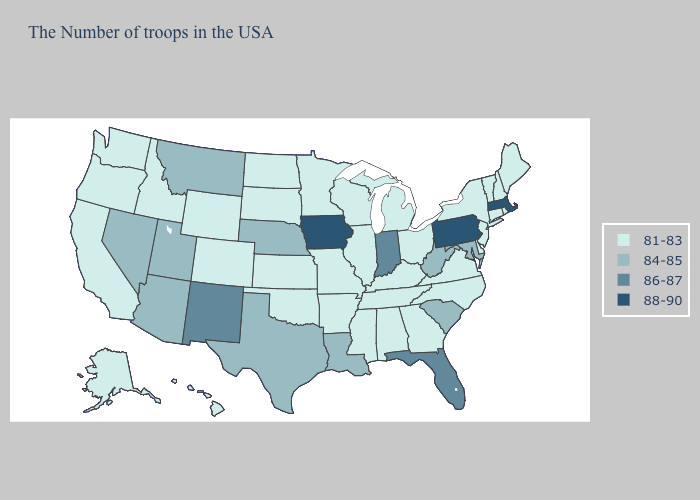Name the states that have a value in the range 88-90?
Be succinct. Massachusetts, Pennsylvania, Iowa. Name the states that have a value in the range 84-85?
Write a very short answer. Maryland, South Carolina, West Virginia, Louisiana, Nebraska, Texas, Utah, Montana, Arizona, Nevada. Name the states that have a value in the range 88-90?
Answer briefly. Massachusetts, Pennsylvania, Iowa. Which states have the highest value in the USA?
Write a very short answer. Massachusetts, Pennsylvania, Iowa. Which states have the lowest value in the USA?
Answer briefly. Maine, Rhode Island, New Hampshire, Vermont, Connecticut, New York, New Jersey, Delaware, Virginia, North Carolina, Ohio, Georgia, Michigan, Kentucky, Alabama, Tennessee, Wisconsin, Illinois, Mississippi, Missouri, Arkansas, Minnesota, Kansas, Oklahoma, South Dakota, North Dakota, Wyoming, Colorado, Idaho, California, Washington, Oregon, Alaska, Hawaii. What is the value of Georgia?
Write a very short answer. 81-83. Name the states that have a value in the range 88-90?
Short answer required. Massachusetts, Pennsylvania, Iowa. Name the states that have a value in the range 81-83?
Concise answer only. Maine, Rhode Island, New Hampshire, Vermont, Connecticut, New York, New Jersey, Delaware, Virginia, North Carolina, Ohio, Georgia, Michigan, Kentucky, Alabama, Tennessee, Wisconsin, Illinois, Mississippi, Missouri, Arkansas, Minnesota, Kansas, Oklahoma, South Dakota, North Dakota, Wyoming, Colorado, Idaho, California, Washington, Oregon, Alaska, Hawaii. What is the highest value in states that border North Carolina?
Concise answer only. 84-85. What is the value of Alabama?
Quick response, please. 81-83. How many symbols are there in the legend?
Concise answer only. 4. What is the value of Ohio?
Quick response, please. 81-83. What is the highest value in states that border Louisiana?
Write a very short answer. 84-85. Does Minnesota have a higher value than Ohio?
Concise answer only. No. Among the states that border New Mexico , does Oklahoma have the highest value?
Give a very brief answer. No. 